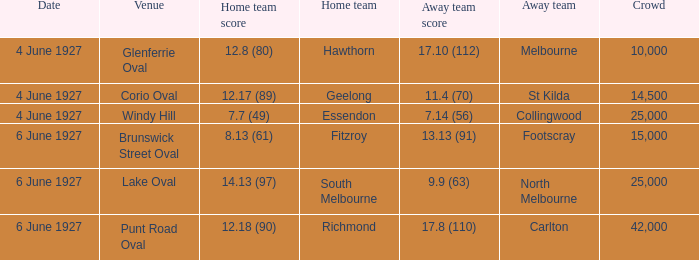How many people in the crowd with north melbourne as an away team? 25000.0. 